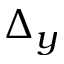<formula> <loc_0><loc_0><loc_500><loc_500>\Delta _ { y }</formula> 